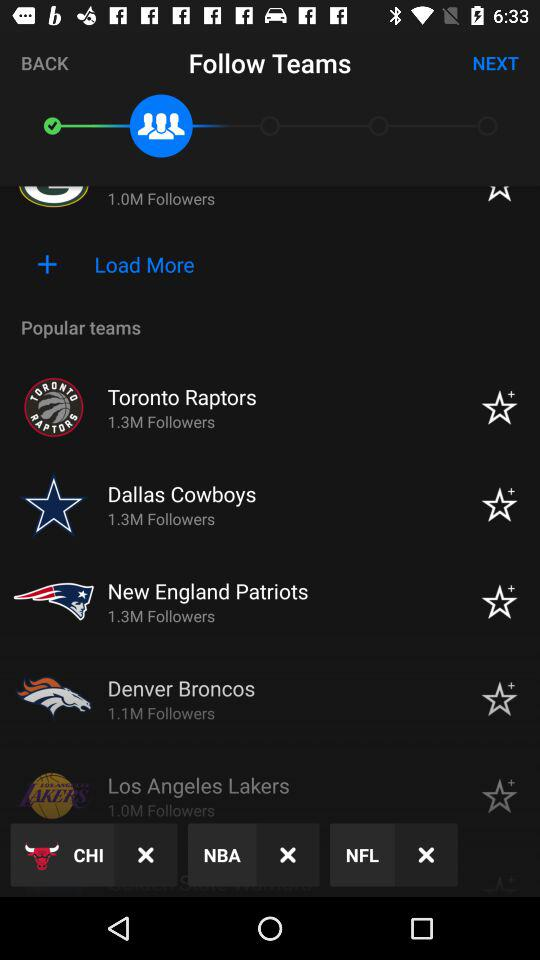How many followers are there of the Toronto Raptors? There are 1.3 million followers of the Toronto Raptors. 